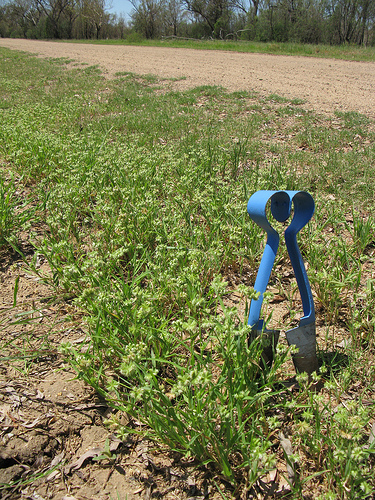<image>
Can you confirm if the metal is in the ground? Yes. The metal is contained within or inside the ground, showing a containment relationship. 